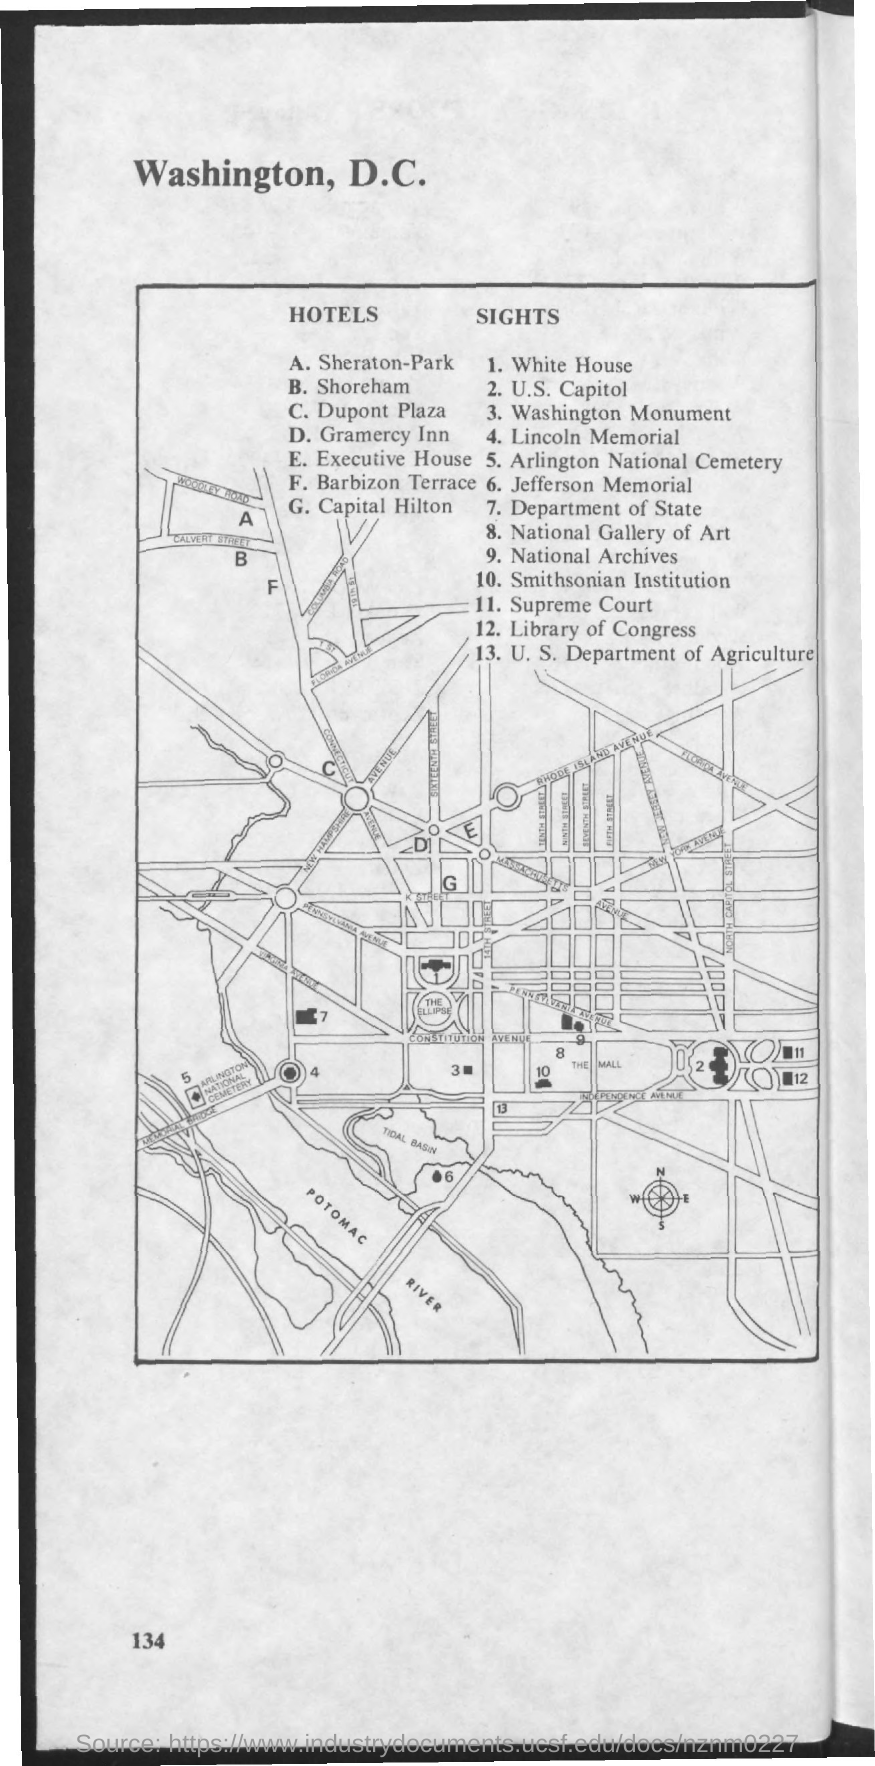What is the first title in the document?
Offer a very short reply. Washington, D.C. Capital Hilton hotel is represented by which letter?
Give a very brief answer. G. The number 1 represents which sight?
Ensure brevity in your answer.  White House. The number 11 represents which sight?
Your answer should be very brief. Supreme Court. 